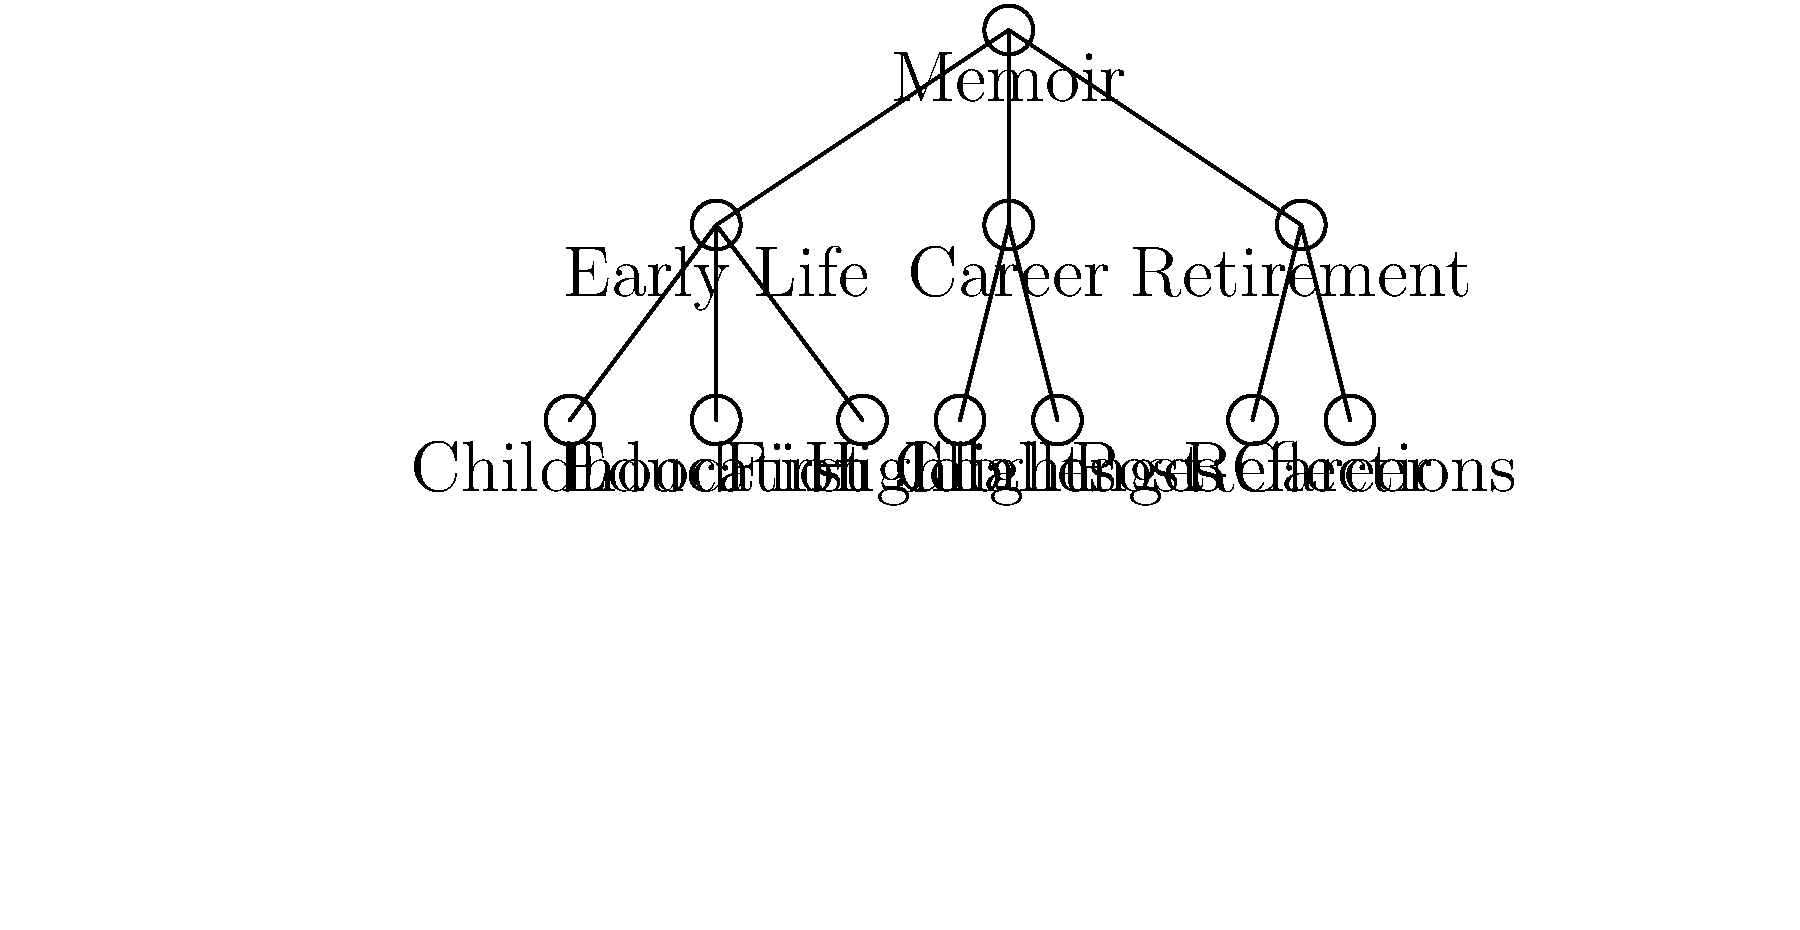As a book club member, you've been tasked with creating a visual representation of the retired sportscaster's memoir chapter structure. Based on the tree diagram provided, how many main sections does the memoir contain, and what is the total number of subsections across all main sections? To answer this question, we need to analyze the tree diagram of the memoir's structure:

1. First, identify the main sections:
   - The diagram shows three main branches stemming from the "Memoir" root:
     a) Early Life
     b) Career
     c) Retirement

2. Count the number of main sections:
   - There are 3 main sections.

3. Next, count the subsections for each main section:
   a) Early Life has 3 subsections:
      - Childhood
      - Education
      - First Job
   b) Career has 2 subsections:
      - Highlights
      - Challenges
   c) Retirement has 2 subsections:
      - Post-Career
      - Reflections

4. Calculate the total number of subsections:
   - Total subsections = 3 + 2 + 2 = 7

5. Combine the information:
   - The memoir contains 3 main sections.
   - The total number of subsections across all main sections is 7.
Answer: 3 main sections, 7 subsections 